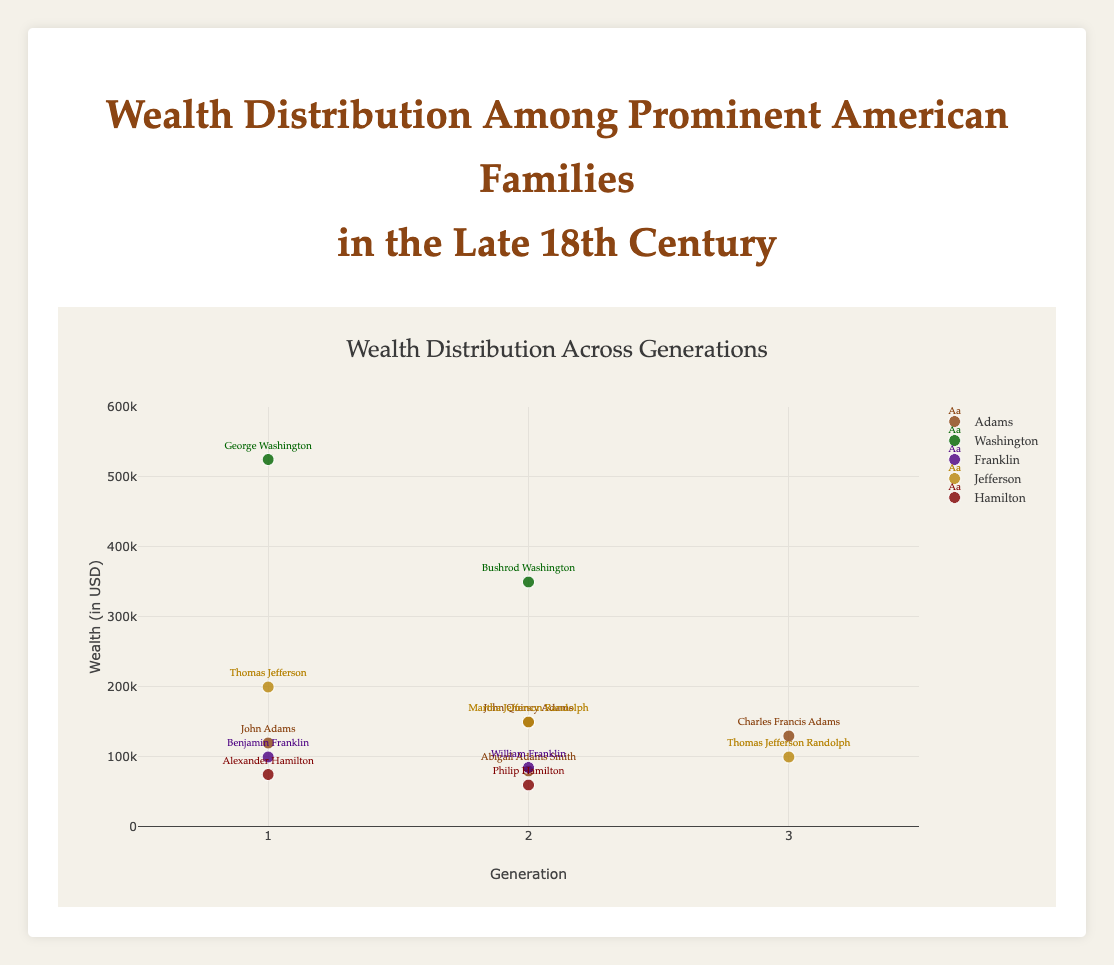What's the title of the plot? The title of the plot is prominently displayed at the top of the figure. The title indicates the subject of the data being visualized.
Answer: Wealth Distribution Among Prominent American Families in the Late 18th Century How many generations are represented in the Adams family? Looking at the x-axis, where the generations are plotted, and checking the markers for the Adams family, we can see there are three distinct x-values representing three generations.
Answer: 3 Who has the highest wealth in the Washington family? Each individual marker text provides the individual's name. Among the Washington family, George Washington has the highest wealth, represented by the tallest y-axis value.
Answer: George Washington Which family has the lowest wealth for any individual? By observing each family's markers along the y-axis, the lowest point among all families belongs to Philip Hamilton from the Hamilton family.
Answer: Hamilton What's the wealth of Abigail Adams Smith? Locate Abigail Adams Smith's marker in the Adams family group. Her wealth is directly emphasized by her marker's position on the y-axis.
Answer: 80000 Which individual in the Jefferson family had the highest wealth? By finding the markers for each Jefferson family member along the y-axis, Thomas Jefferson is seen with the highest wealth.
Answer: Thomas Jefferson By how much did the wealth of Bushrod Washington differ from George Washington? Check the y-axis values for both George Washington and Bushrod Washington and calculate the difference between 525000 and 350000.
Answer: 175000 What's the average wealth of the first generation individuals? Identify first-generation individuals, sum their wealths (John Adams 120000, George Washington 525000, Benjamin Franklin 100000, Thomas Jefferson 200000, Alexander Hamilton 75000), and divide by 5. (120000 + 525000 + 100000 + 200000 + 75000) / 5 = 204000
Answer: 204000 Who had more wealth, Abigail Adams Smith or William Franklin? Comparing the y-axis positions for Abigail Adams Smith (80000) and William Franklin (85000), William Franklin had more wealth.
Answer: William Franklin What's the total wealth of the first two generations in the Adams family? Sum the wealths of John Adams (120000), John Quincy Adams (150000), and Abigail Adams Smith (80000). (120000 + 150000 + 80000)
Answer: 350000 